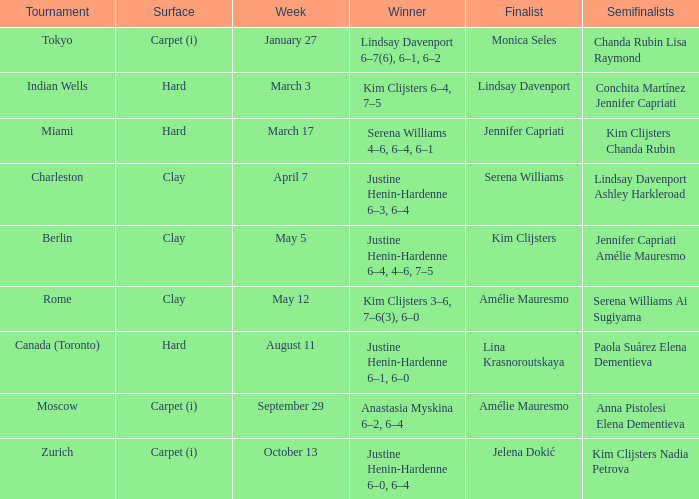Who was the winner against finalist Lina Krasnoroutskaya? Justine Henin-Hardenne 6–1, 6–0. 